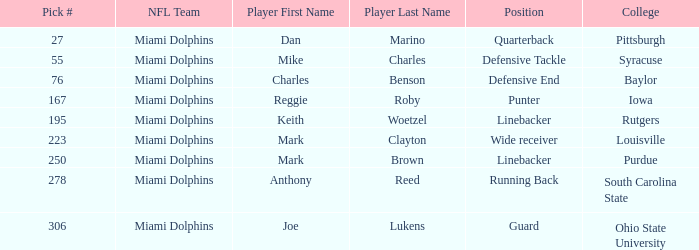Which Position has a Pick # lower than 278 for Player Charles Benson? Defensive End. 